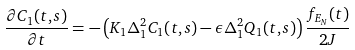Convert formula to latex. <formula><loc_0><loc_0><loc_500><loc_500>\frac { \partial C _ { 1 } ( t , s ) } { \partial t } = - \left ( K _ { 1 } \Delta _ { 1 } ^ { 2 } C _ { 1 } ( t , s ) - \epsilon \Delta _ { 1 } ^ { 2 } Q _ { 1 } ( t , s ) \right ) \frac { f _ { E _ { N } } ( t ) } { 2 J }</formula> 